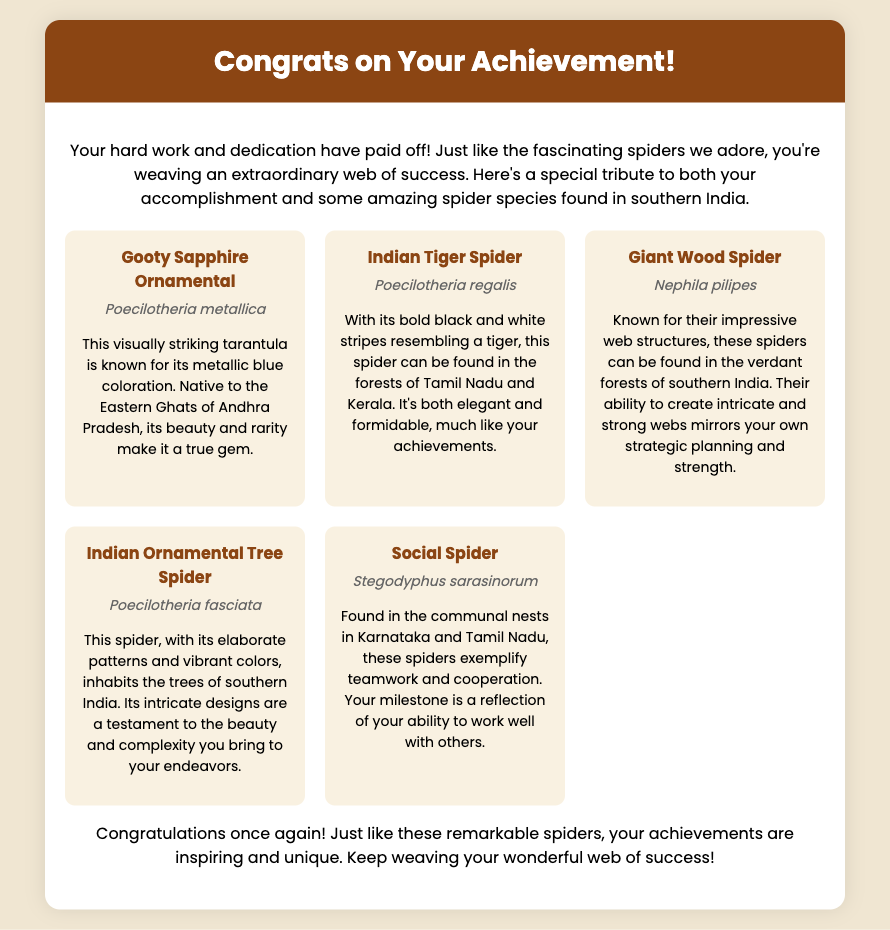What is the title of the card? The title of the card is prominently displayed at the top of the card.
Answer: Congrats on Your Achievement! How many spider species are featured in the infographic? The infographic includes five different spider species.
Answer: Five What is the scientific name of the Gooty Sapphire Ornamental? The scientific name is provided below the common name in the spider card.
Answer: Poecilotheria metallica Which spider is known for its impressive web structures? The description mentions the spider's web structures, indicating its uniqueness.
Answer: Giant Wood Spider What is the habitat of the Social Spider? The card specifies the locations where the Social Spider can be found.
Answer: Karnataka and Tamil Nadu In the introduction, what metaphor is used to describe the recipient's accomplishments? The introduction uses a metaphor related to spiders to illustrate achievements.
Answer: Weaving an extraordinary web of success Which spider is noted for its bold black and white stripes? The card specifically describes this spider with its striking color pattern.
Answer: Indian Tiger Spider What quality does the Giant Wood Spider mirror regarding the recipient? The text compares this spider's attributes to a particular quality of the person.
Answer: Strategic planning and strength 